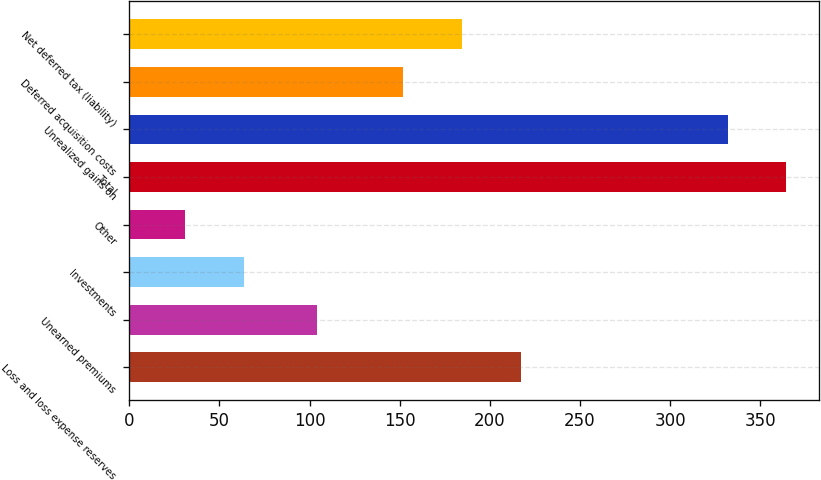Convert chart. <chart><loc_0><loc_0><loc_500><loc_500><bar_chart><fcel>Loss and loss expense reserves<fcel>Unearned premiums<fcel>Investments<fcel>Other<fcel>Total<fcel>Unrealized gains on<fcel>Deferred acquisition costs<fcel>Net deferred tax (liability)<nl><fcel>217.2<fcel>104<fcel>63.6<fcel>31<fcel>364.6<fcel>332<fcel>152<fcel>184.6<nl></chart> 